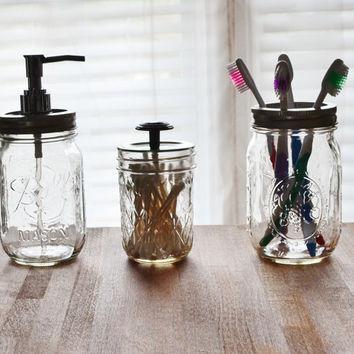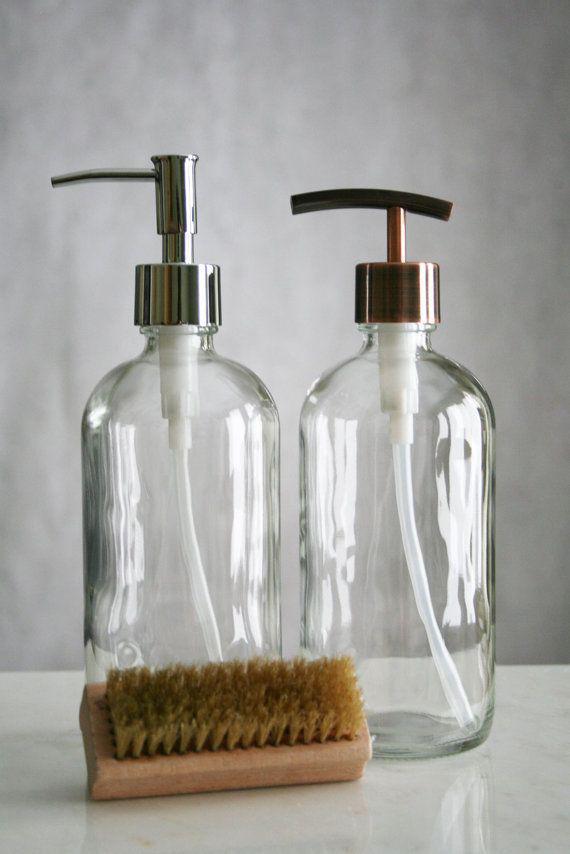The first image is the image on the left, the second image is the image on the right. Analyze the images presented: Is the assertion "At least one image shows exactly three containers." valid? Answer yes or no. Yes. The first image is the image on the left, the second image is the image on the right. Analyze the images presented: Is the assertion "In each image the soap dispenser is filled with liquid." valid? Answer yes or no. No. 